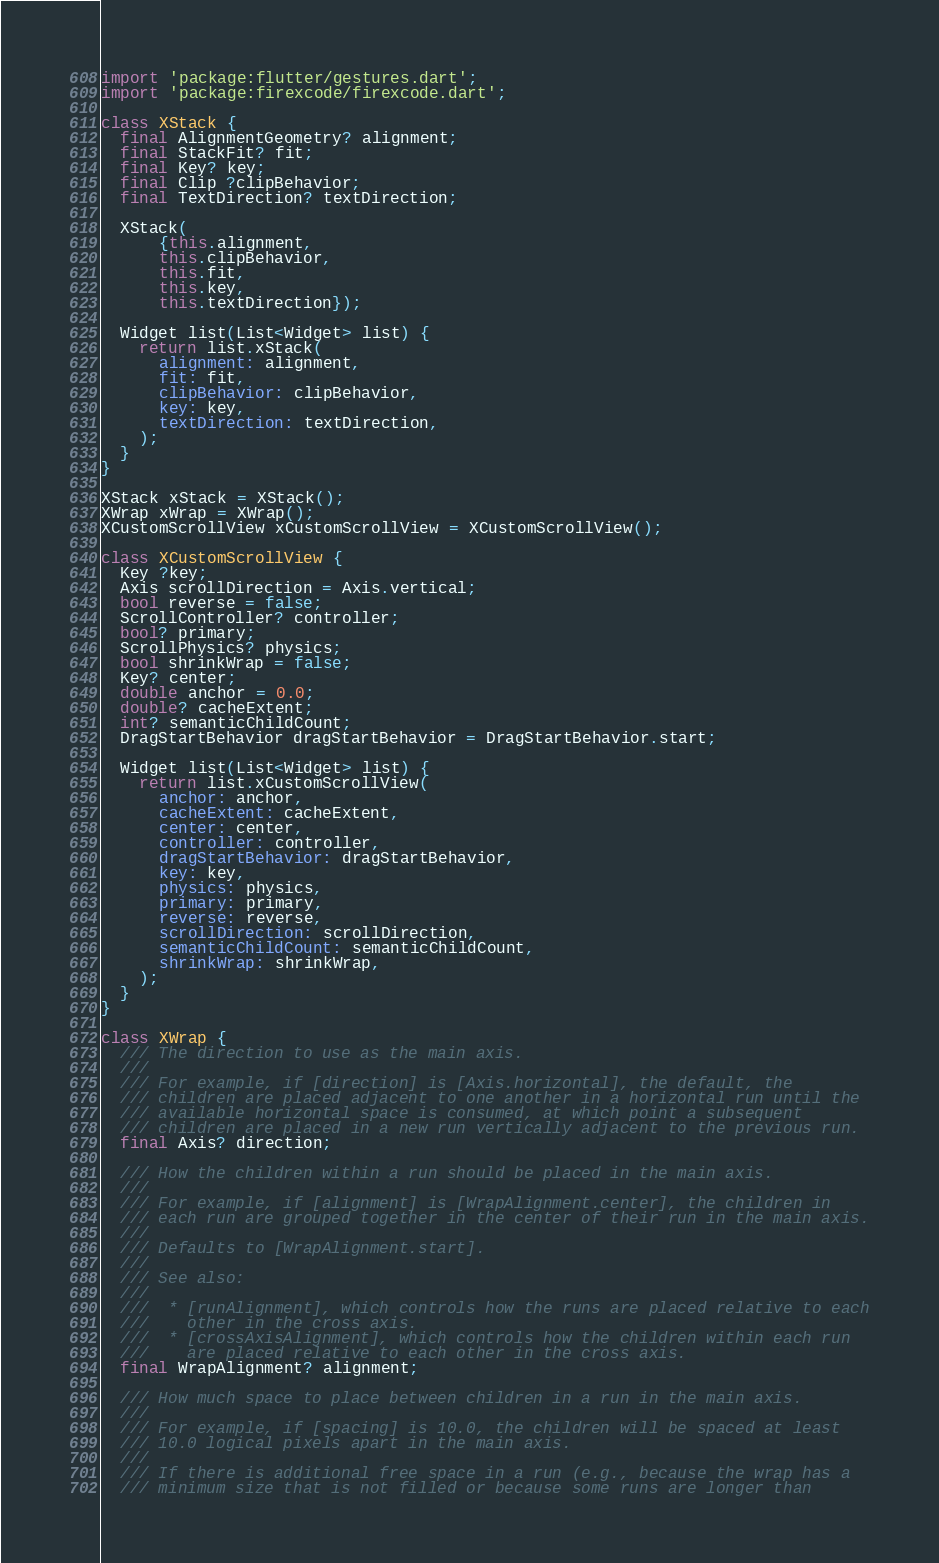<code> <loc_0><loc_0><loc_500><loc_500><_Dart_>import 'package:flutter/gestures.dart';
import 'package:firexcode/firexcode.dart';

class XStack {
  final AlignmentGeometry? alignment;
  final StackFit? fit;
  final Key? key;
  final Clip ?clipBehavior;
  final TextDirection? textDirection;

  XStack(
      {this.alignment,
      this.clipBehavior,
      this.fit,
      this.key,
      this.textDirection});

  Widget list(List<Widget> list) {
    return list.xStack(
      alignment: alignment,
      fit: fit,
      clipBehavior: clipBehavior,
      key: key,
      textDirection: textDirection,
    );
  }
}

XStack xStack = XStack();
XWrap xWrap = XWrap();
XCustomScrollView xCustomScrollView = XCustomScrollView();

class XCustomScrollView {
  Key ?key;
  Axis scrollDirection = Axis.vertical;
  bool reverse = false;
  ScrollController? controller;
  bool? primary;
  ScrollPhysics? physics;
  bool shrinkWrap = false;
  Key? center;
  double anchor = 0.0;
  double? cacheExtent;
  int? semanticChildCount;
  DragStartBehavior dragStartBehavior = DragStartBehavior.start;

  Widget list(List<Widget> list) {
    return list.xCustomScrollView(
      anchor: anchor,
      cacheExtent: cacheExtent,
      center: center,
      controller: controller,
      dragStartBehavior: dragStartBehavior,
      key: key,
      physics: physics,
      primary: primary,
      reverse: reverse,
      scrollDirection: scrollDirection,
      semanticChildCount: semanticChildCount,
      shrinkWrap: shrinkWrap,
    );
  }
}

class XWrap {
  /// The direction to use as the main axis.
  ///
  /// For example, if [direction] is [Axis.horizontal], the default, the
  /// children are placed adjacent to one another in a horizontal run until the
  /// available horizontal space is consumed, at which point a subsequent
  /// children are placed in a new run vertically adjacent to the previous run.
  final Axis? direction;

  /// How the children within a run should be placed in the main axis.
  ///
  /// For example, if [alignment] is [WrapAlignment.center], the children in
  /// each run are grouped together in the center of their run in the main axis.
  ///
  /// Defaults to [WrapAlignment.start].
  ///
  /// See also:
  ///
  ///  * [runAlignment], which controls how the runs are placed relative to each
  ///    other in the cross axis.
  ///  * [crossAxisAlignment], which controls how the children within each run
  ///    are placed relative to each other in the cross axis.
  final WrapAlignment? alignment;

  /// How much space to place between children in a run in the main axis.
  ///
  /// For example, if [spacing] is 10.0, the children will be spaced at least
  /// 10.0 logical pixels apart in the main axis.
  ///
  /// If there is additional free space in a run (e.g., because the wrap has a
  /// minimum size that is not filled or because some runs are longer than</code> 